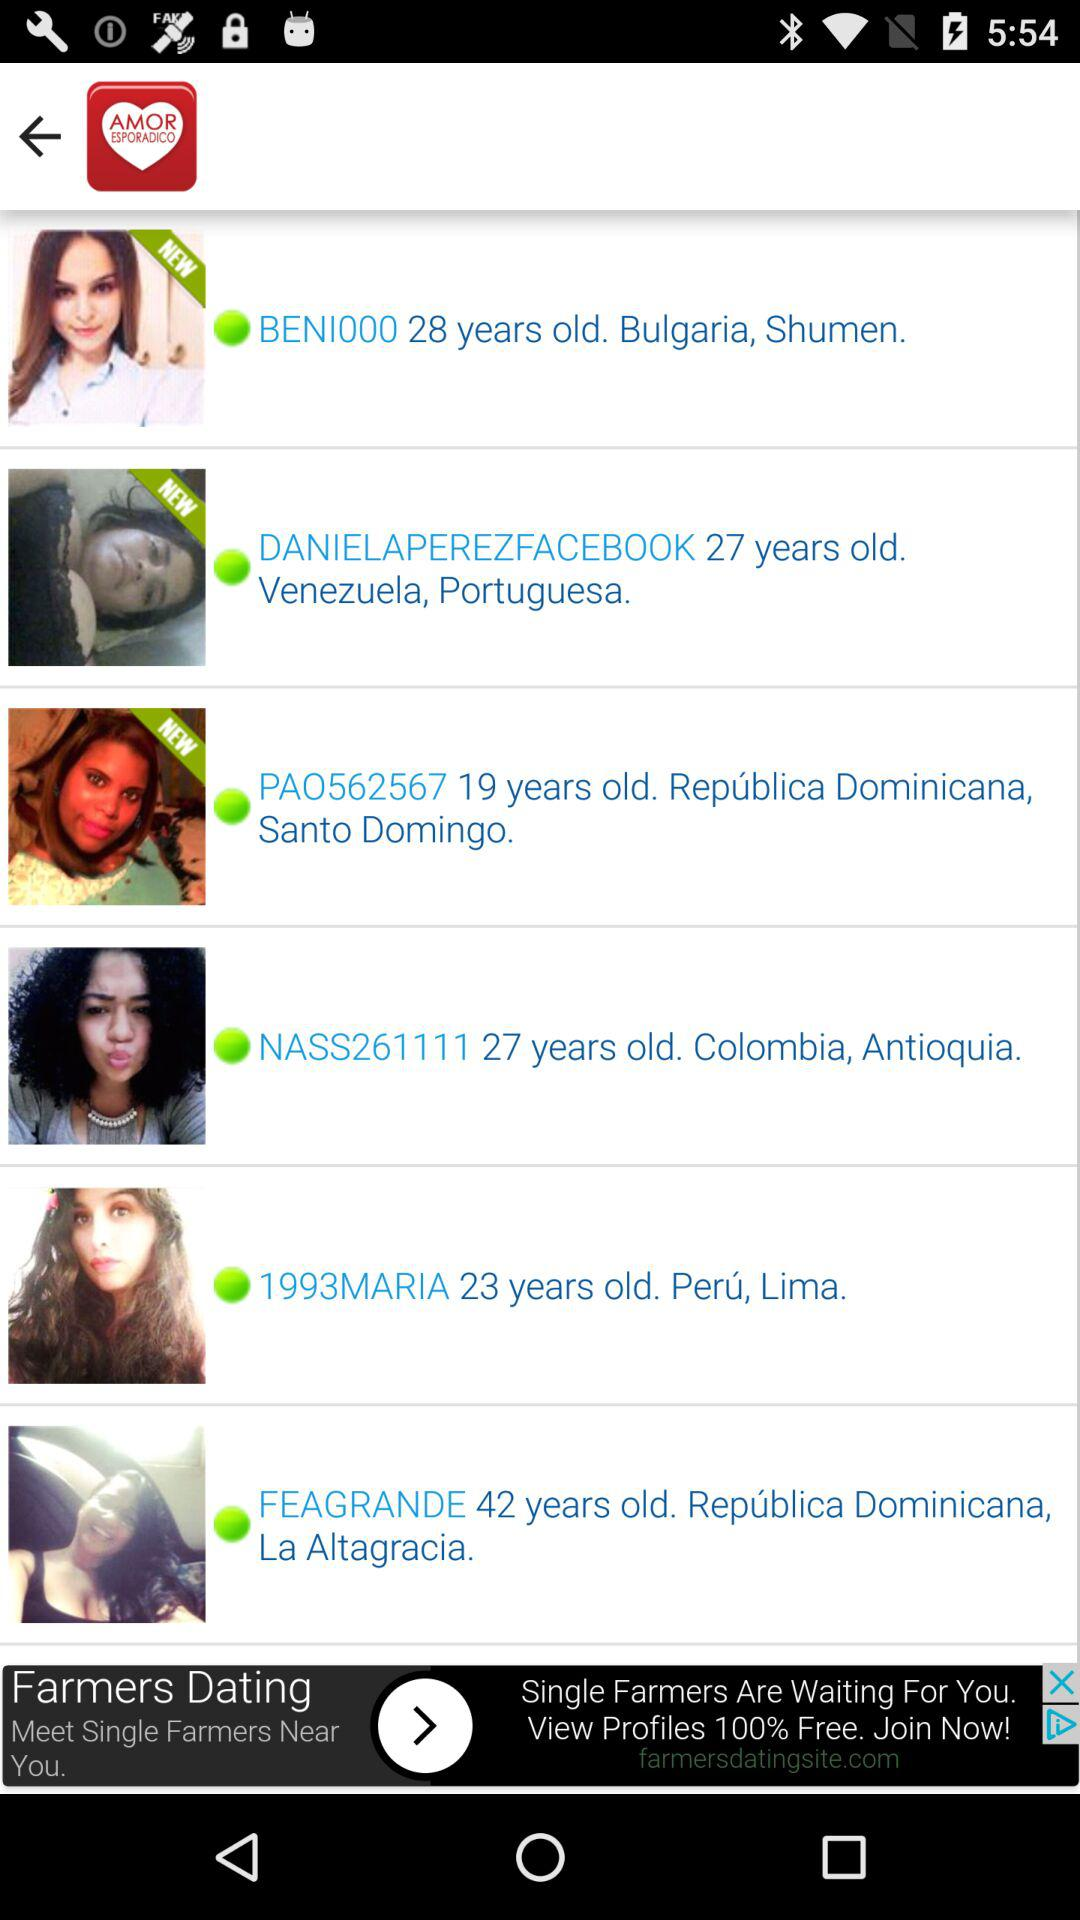What is the application name? The application name is "AmorEsporadico". 